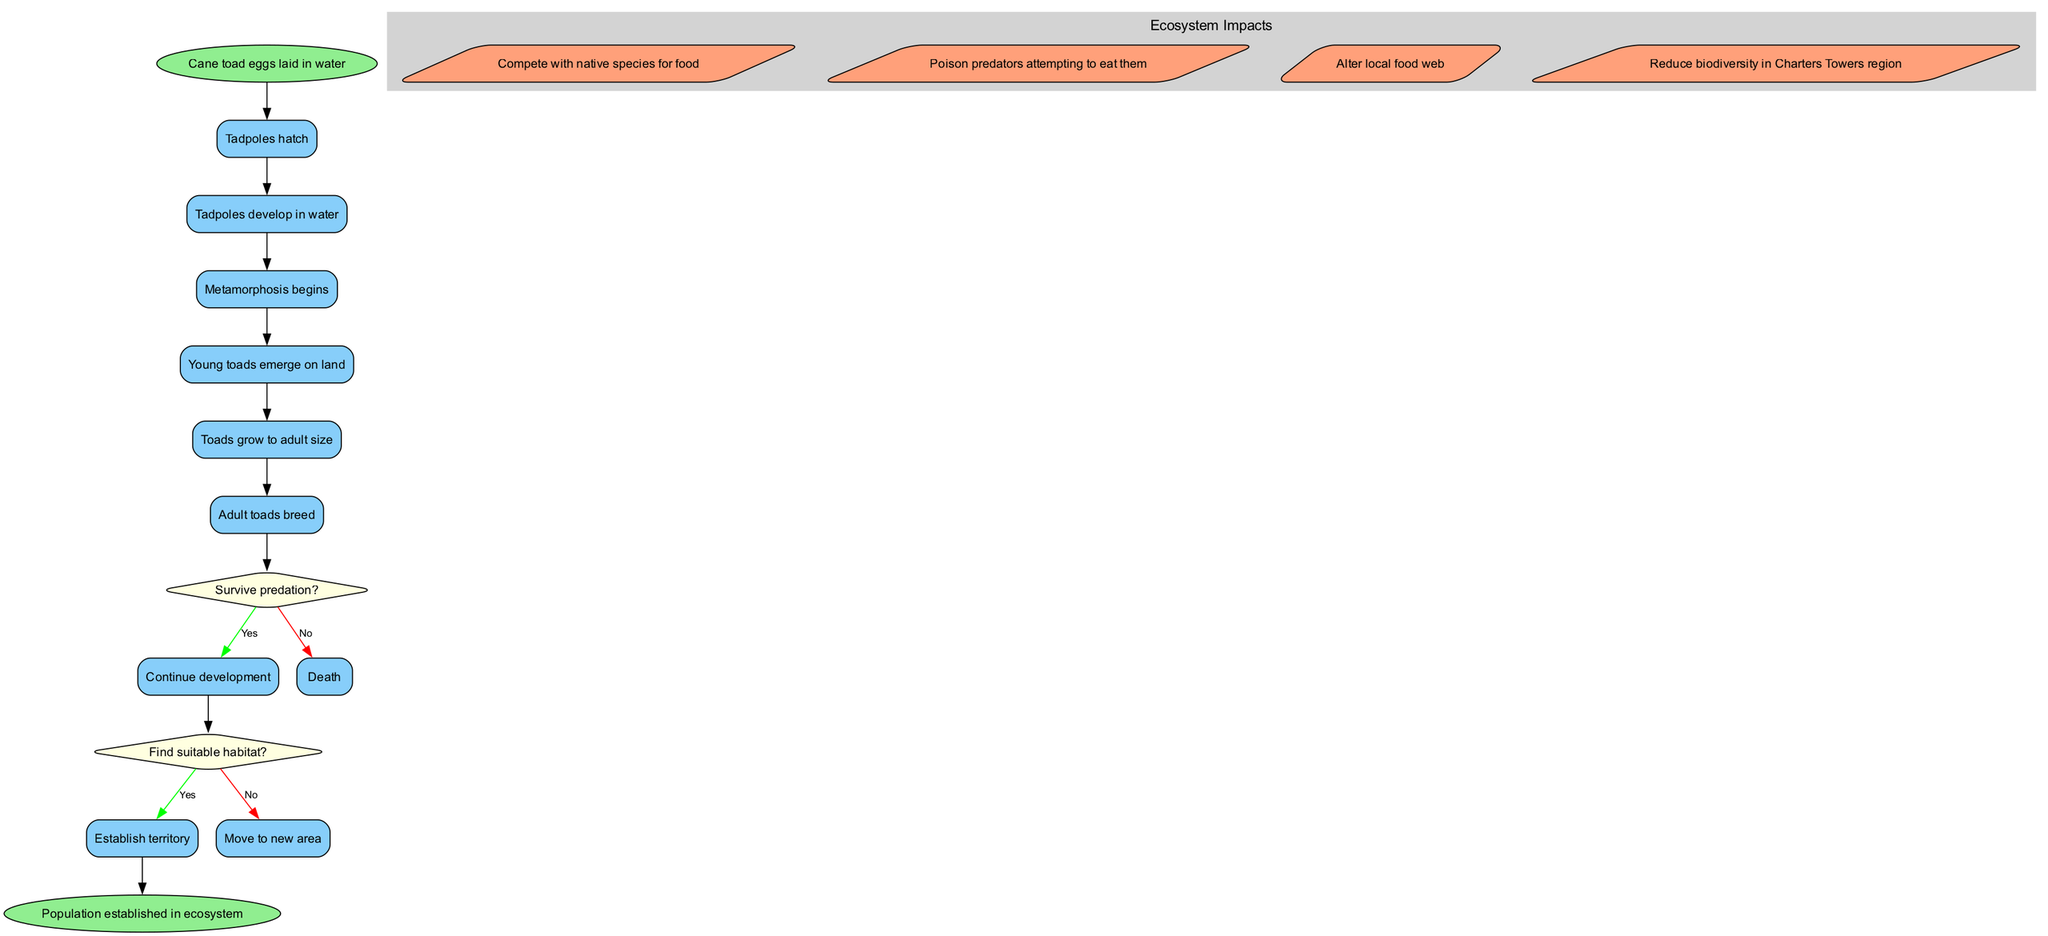What is the first activity after the initial node? The initial node states "Cane toad eggs laid in water", and the first activity that follows this node in the diagram is "Tadpoles hatch".
Answer: Tadpoles hatch How many decision points are there in the diagram? The diagram features two decision points related to survival and habitat, which can be counted easily as each decision node is distinct and connected to other activities.
Answer: 2 What happens if tadpoles do not survive predation? According to the decision node in the diagram, if tadpoles do not survive predation, the path leads to "Death". This is a direct consequence of failing to survive during development.
Answer: Death What is the impact of adult toads competing with native species? The diagram indicates that adult toads competing with native species leads to "Reduce biodiversity in Charters Towers region". This summarizes the consequence of their competition in the ecosystem.
Answer: Reduce biodiversity in Charters Towers region What activity follows "Young toads emerge on land"? After the activity, "Young toads emerge on land", the next step indicated in the diagram is "Toads grow to adult size". This shows the progression in the life cycle.
Answer: Toads grow to adult size What do adult toads do in their life cycle? The diagram shows that adult toads engage in "Adult toads breed" as one of their key activities, which indicates the continuation of their life cycle.
Answer: Adult toads breed How is the final node connected to the previous activities? The final node labeled "Population established in ecosystem" is connected from the last activity, which is a result of successful processes shown through previous activities, decisions, and established impacts.
Answer: Population established in ecosystem What is one question asked at a decision point? One of the decision questions presented in the diagram is "Survive predation?", which is crucial for determining the success of tadpole development.
Answer: Survive predation? 